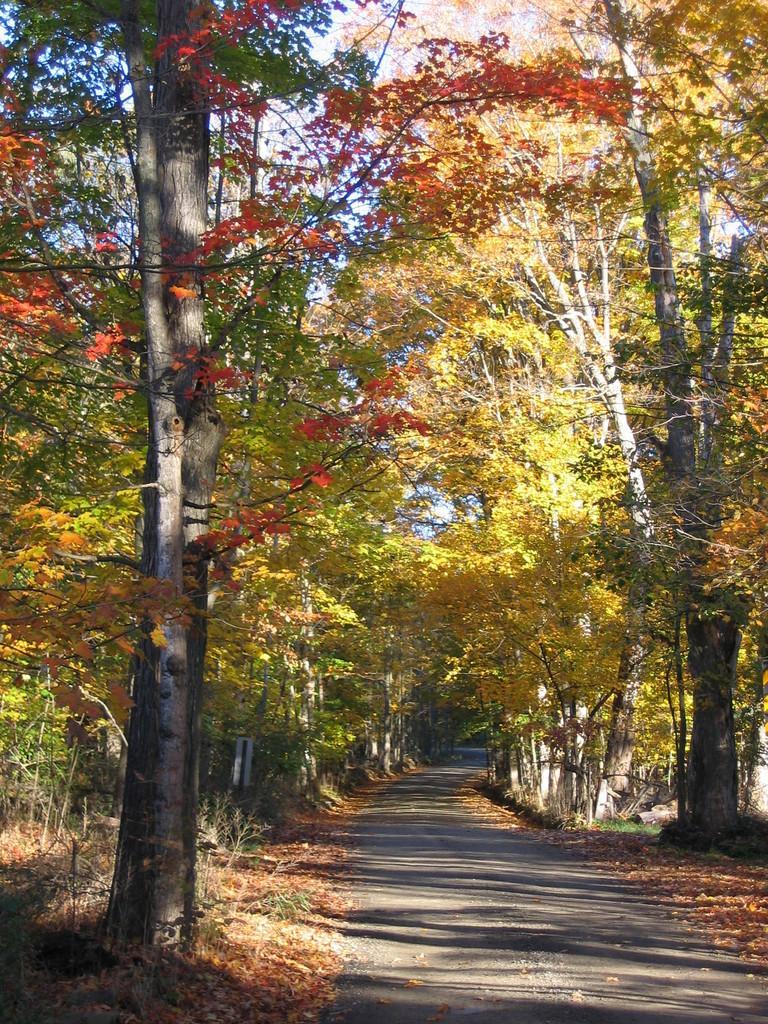How would you summarize this image in a sentence or two? In this picture I can see many trees, plants and grass. At the bottom there is a road, beside that I can see the leaves. At the top there is a sky. 